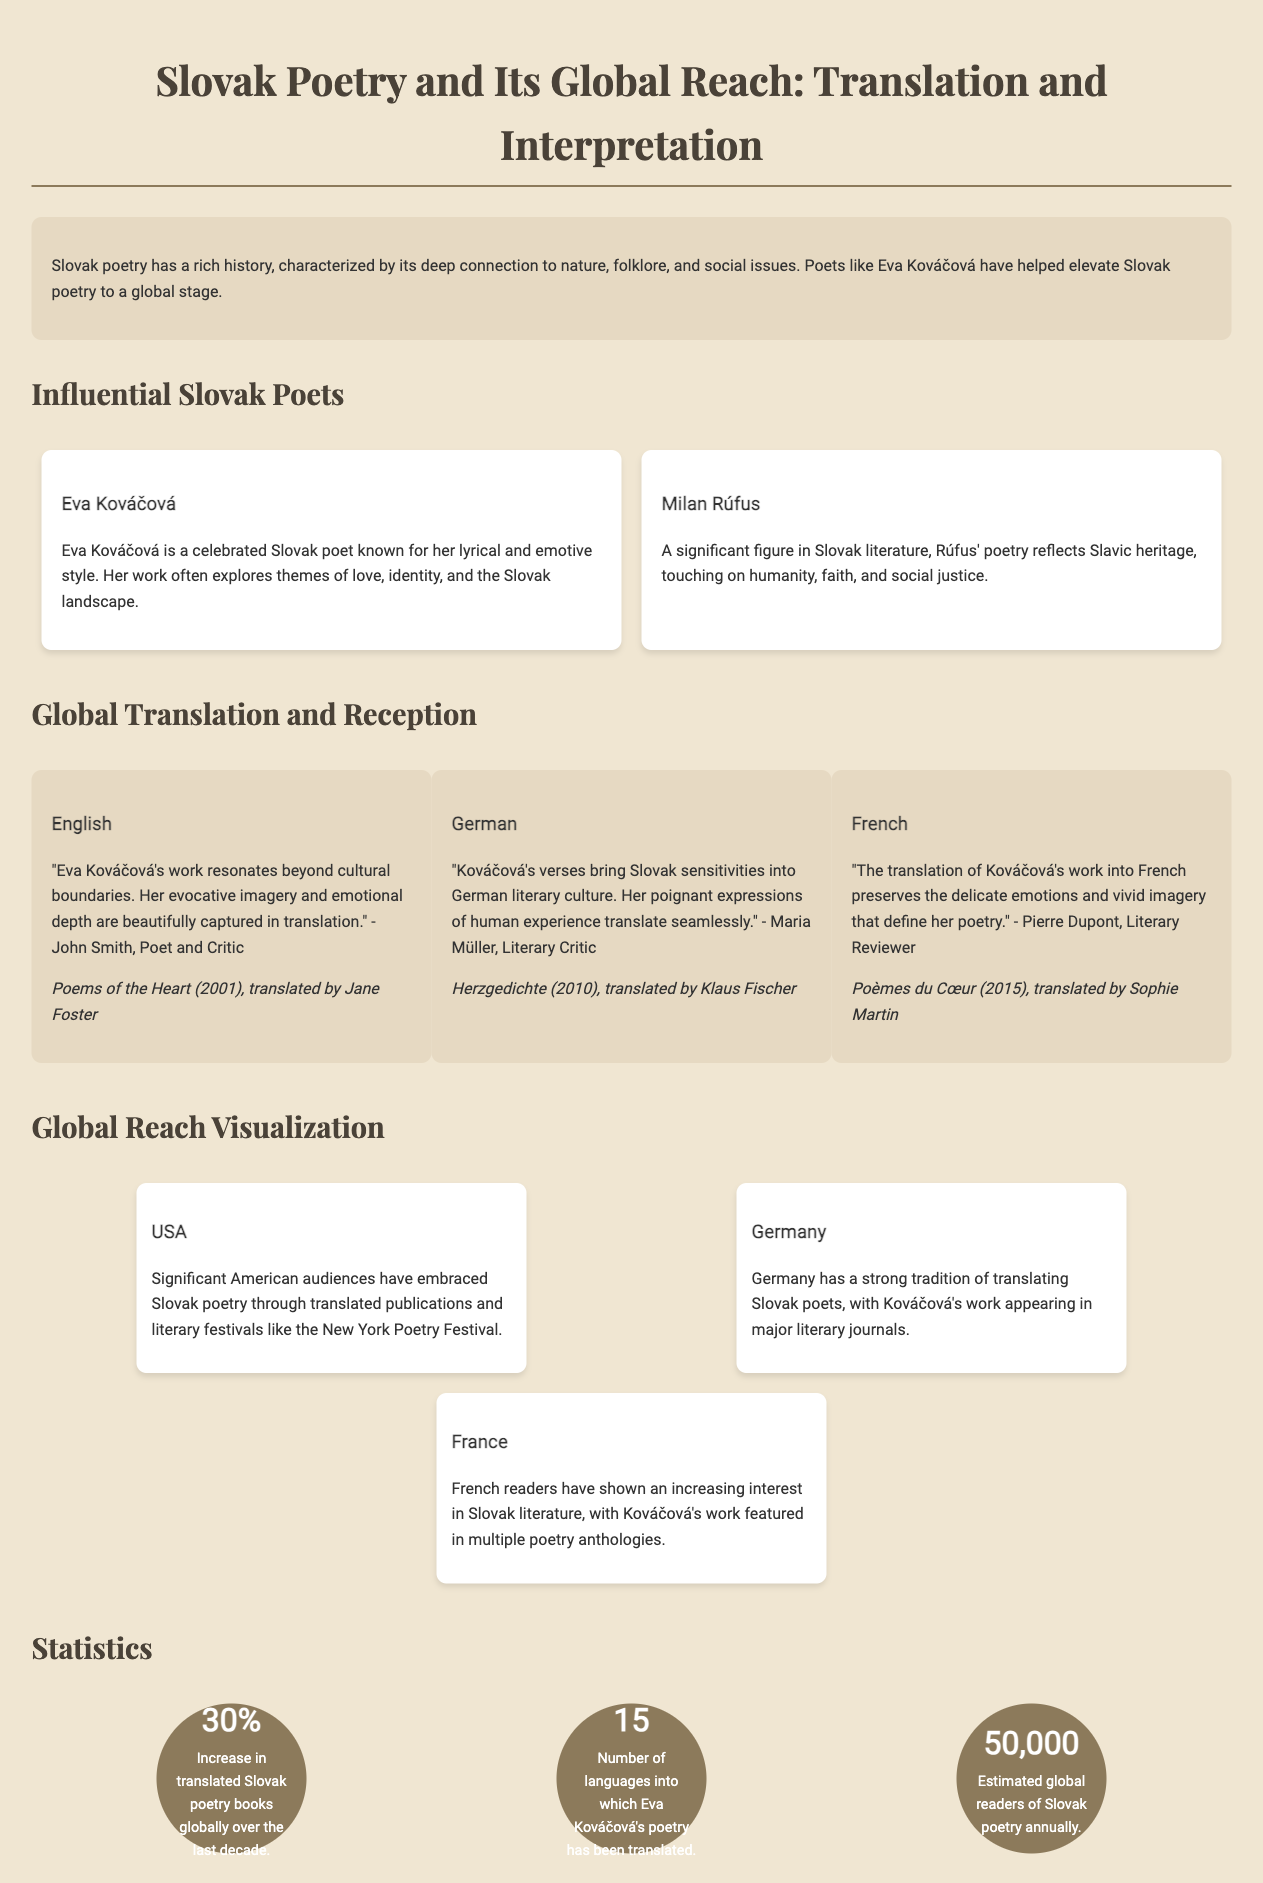What is the title of the document? The title is presented prominently at the top of the document.
Answer: Slovak Poetry and Its Global Reach: Translation and Interpretation Who is the first influential Slovak poet mentioned? The document lists influential Slovak poets, with Kováčová being the first one mentioned.
Answer: Eva Kováčová How many languages has Eva Kováčová's poetry been translated into? The document provides a specific statistic regarding translations of Kováčová's poetry.
Answer: 15 What percentage increase in translated Slovak poetry books has occurred globally? The statistics section includes a specific percentage increase over the last decade.
Answer: 30% Which country has a significant American audience embracing Slovak poetry? The document mentions this country in the context of global reach and audience reception.
Answer: USA What is the estimated number of global readers of Slovak poetry annually? The statistics section offers an estimation regarding readership.
Answer: 50,000 What is the name of the German literary critic who praised Kováčová's work? The translation section includes quotes from critics, naming one of them.
Answer: Maria Müller What is one theme explored in Eva Kováčová's poetry? The introduction discusses themes in Kováčová's poetry, highlighting key elements.
Answer: Love What significant literary event is mentioned in relation to American audiences? The document notes a specific event where Slovak poetry is appreciated.
Answer: New York Poetry Festival 